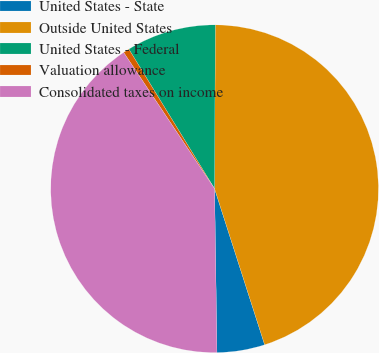Convert chart. <chart><loc_0><loc_0><loc_500><loc_500><pie_chart><fcel>United States - State<fcel>Outside United States<fcel>United States - Federal<fcel>Valuation allowance<fcel>Consolidated taxes on income<nl><fcel>4.71%<fcel>44.99%<fcel>8.83%<fcel>0.6%<fcel>40.87%<nl></chart> 